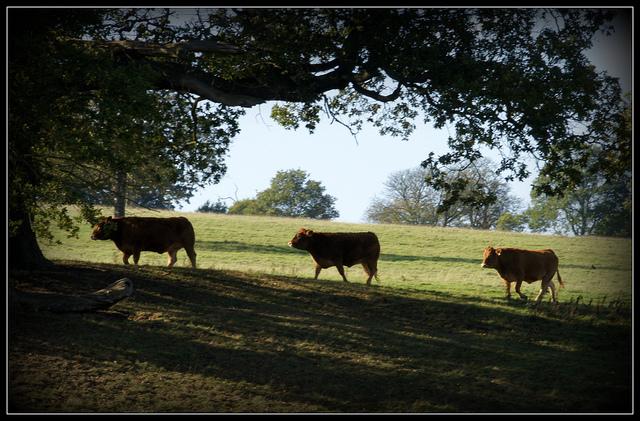Is this an example of perfect photographic filtering and composition?
Give a very brief answer. No. Are the cows going back to their stable?
Concise answer only. Yes. What are the animals doing?
Short answer required. Walking. Is the most focused tree green?
Quick response, please. Yes. Are the cows eating grass?
Short answer required. No. How many cows are there?
Answer briefly. 3. Is that an oak tree closest to the cows?
Give a very brief answer. Yes. 